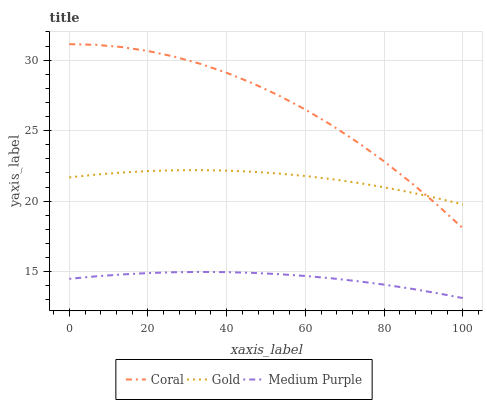Does Medium Purple have the minimum area under the curve?
Answer yes or no. Yes. Does Coral have the maximum area under the curve?
Answer yes or no. Yes. Does Gold have the minimum area under the curve?
Answer yes or no. No. Does Gold have the maximum area under the curve?
Answer yes or no. No. Is Medium Purple the smoothest?
Answer yes or no. Yes. Is Coral the roughest?
Answer yes or no. Yes. Is Gold the smoothest?
Answer yes or no. No. Is Gold the roughest?
Answer yes or no. No. Does Medium Purple have the lowest value?
Answer yes or no. Yes. Does Coral have the lowest value?
Answer yes or no. No. Does Coral have the highest value?
Answer yes or no. Yes. Does Gold have the highest value?
Answer yes or no. No. Is Medium Purple less than Gold?
Answer yes or no. Yes. Is Coral greater than Medium Purple?
Answer yes or no. Yes. Does Coral intersect Gold?
Answer yes or no. Yes. Is Coral less than Gold?
Answer yes or no. No. Is Coral greater than Gold?
Answer yes or no. No. Does Medium Purple intersect Gold?
Answer yes or no. No. 